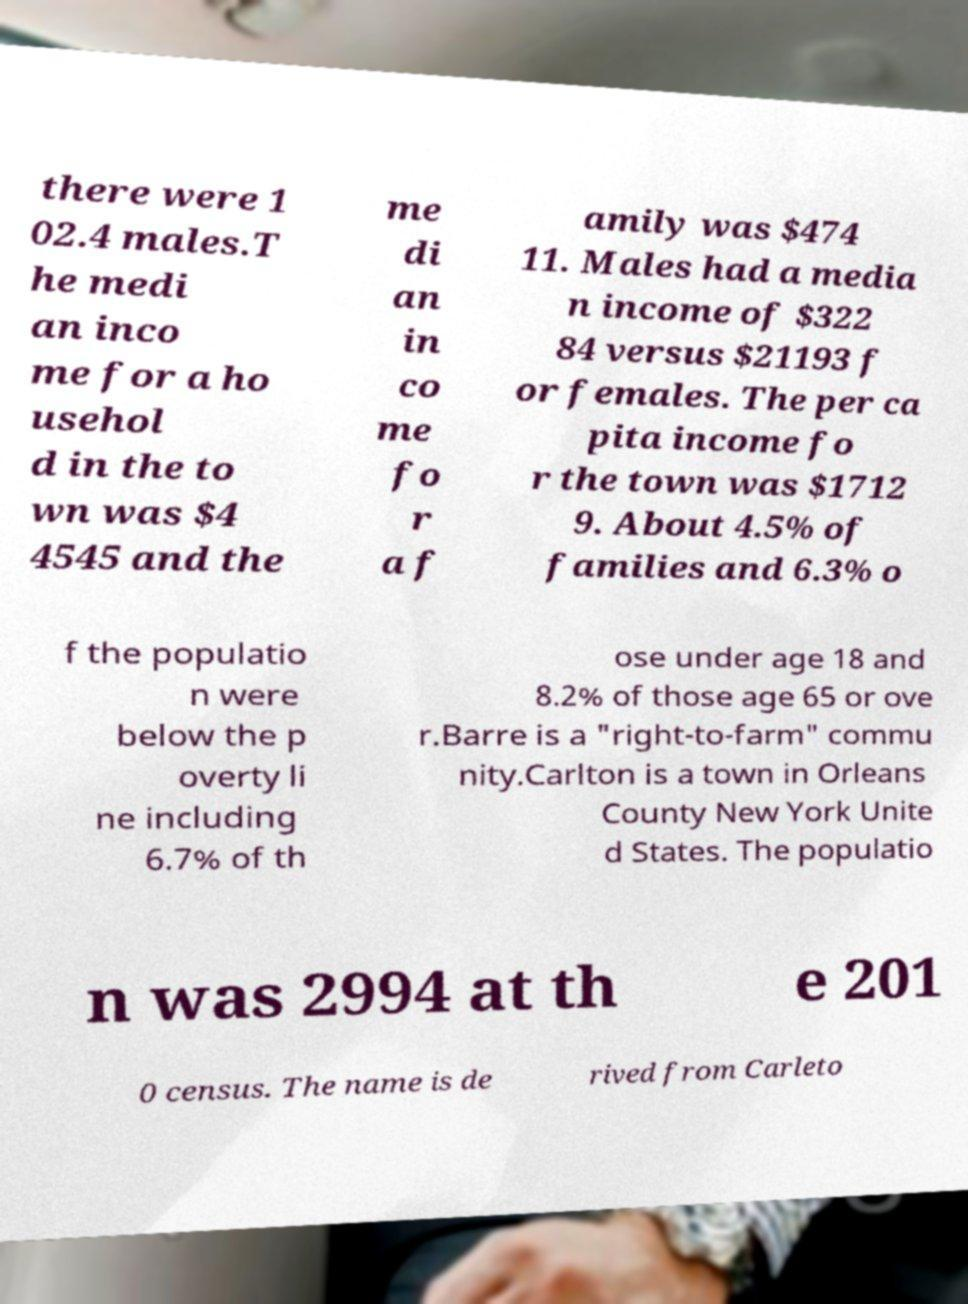Can you read and provide the text displayed in the image?This photo seems to have some interesting text. Can you extract and type it out for me? there were 1 02.4 males.T he medi an inco me for a ho usehol d in the to wn was $4 4545 and the me di an in co me fo r a f amily was $474 11. Males had a media n income of $322 84 versus $21193 f or females. The per ca pita income fo r the town was $1712 9. About 4.5% of families and 6.3% o f the populatio n were below the p overty li ne including 6.7% of th ose under age 18 and 8.2% of those age 65 or ove r.Barre is a "right-to-farm" commu nity.Carlton is a town in Orleans County New York Unite d States. The populatio n was 2994 at th e 201 0 census. The name is de rived from Carleto 